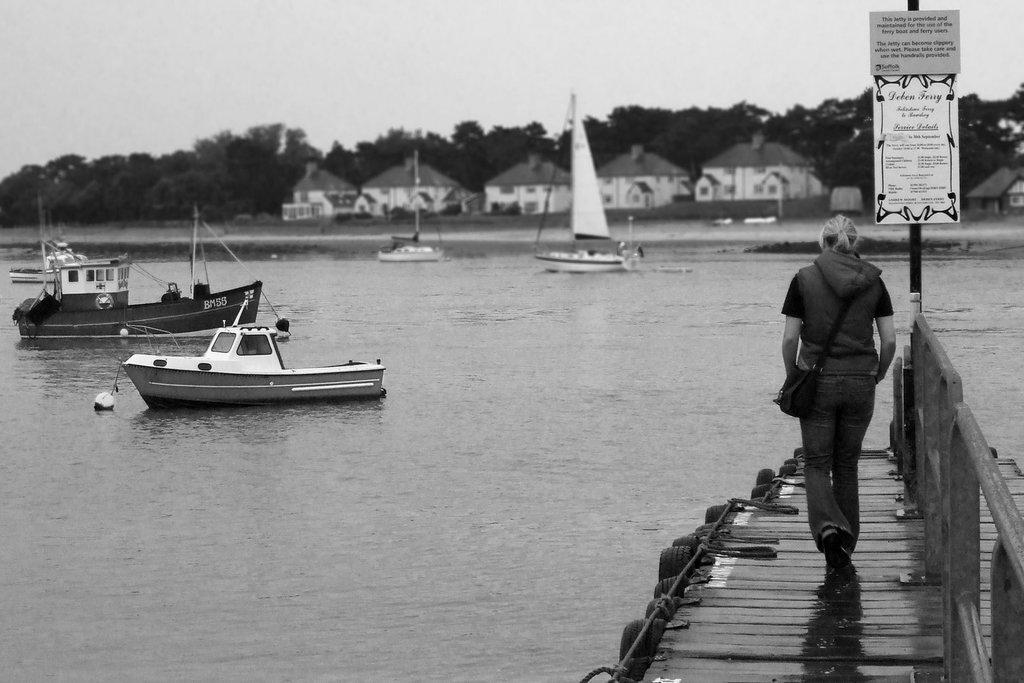Can you describe this image briefly? In the image we can see a woman walking, wearing clothes, shoes and she is carrying a bag. Here we can see the wooden footpath and there are boats in the water. Here we can see the pole and two boards stick to the pole. Here we can see houses, trees and the sky. 